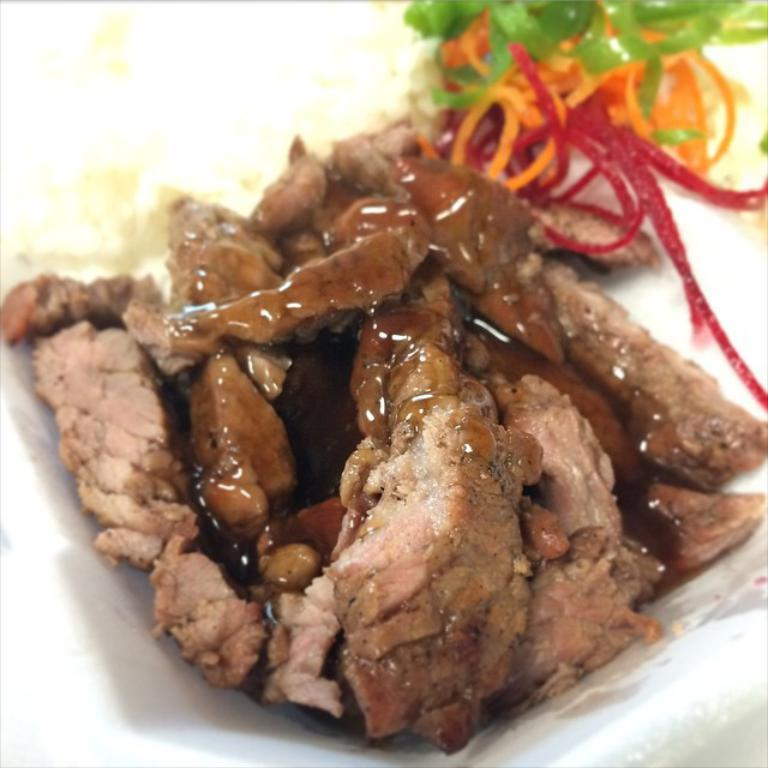What is present on the plate in the image? There are food items on a plate in the image. What type of boot is being used to exercise authority in the image? There is no boot or exercise of authority present in the image; it only features food items on a plate. 